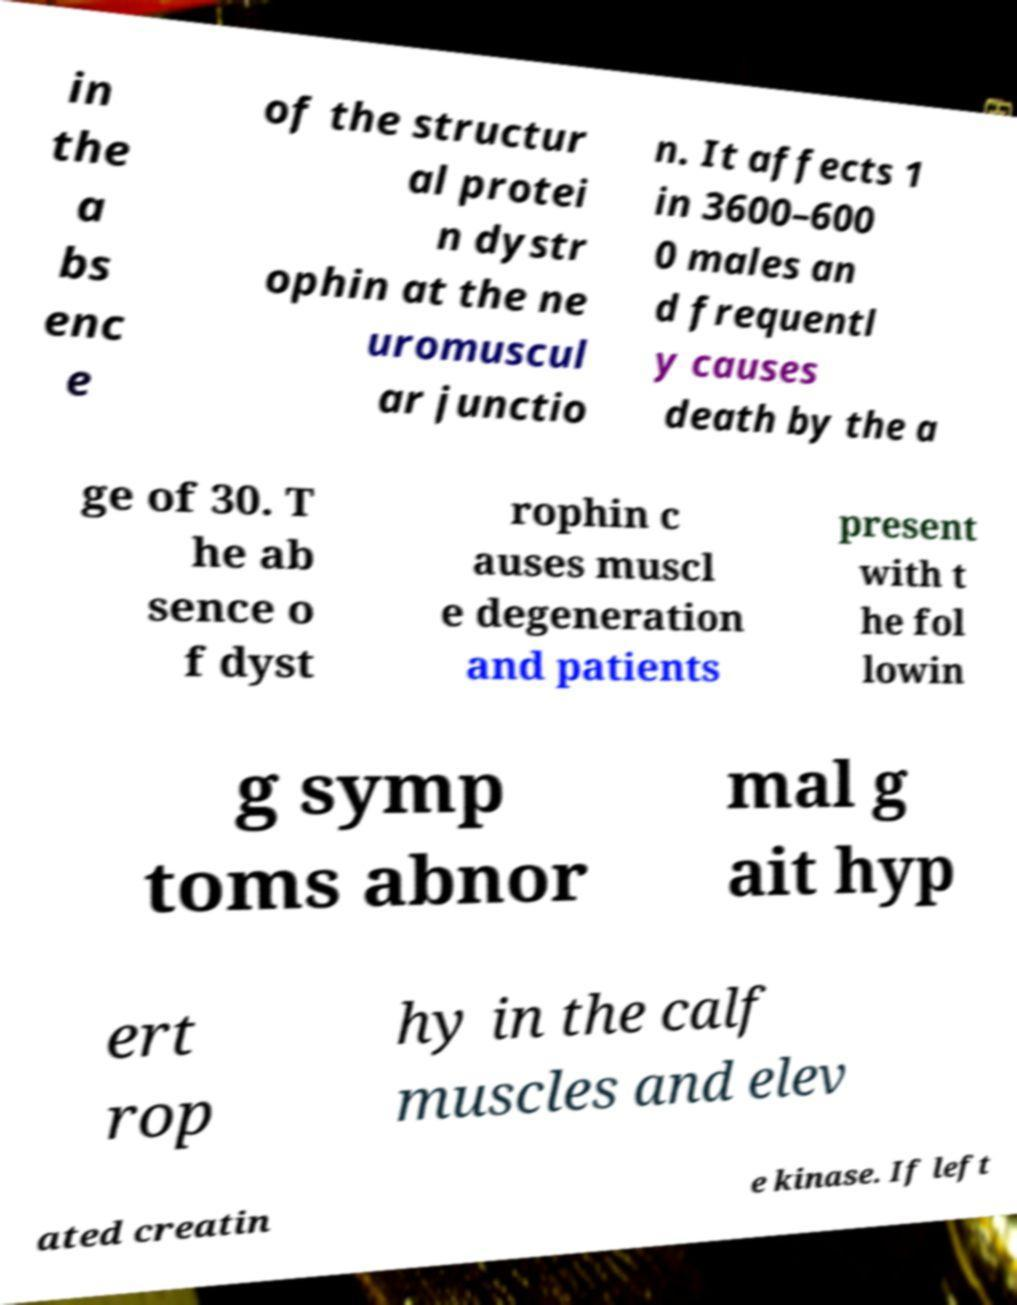Can you read and provide the text displayed in the image?This photo seems to have some interesting text. Can you extract and type it out for me? in the a bs enc e of the structur al protei n dystr ophin at the ne uromuscul ar junctio n. It affects 1 in 3600–600 0 males an d frequentl y causes death by the a ge of 30. T he ab sence o f dyst rophin c auses muscl e degeneration and patients present with t he fol lowin g symp toms abnor mal g ait hyp ert rop hy in the calf muscles and elev ated creatin e kinase. If left 